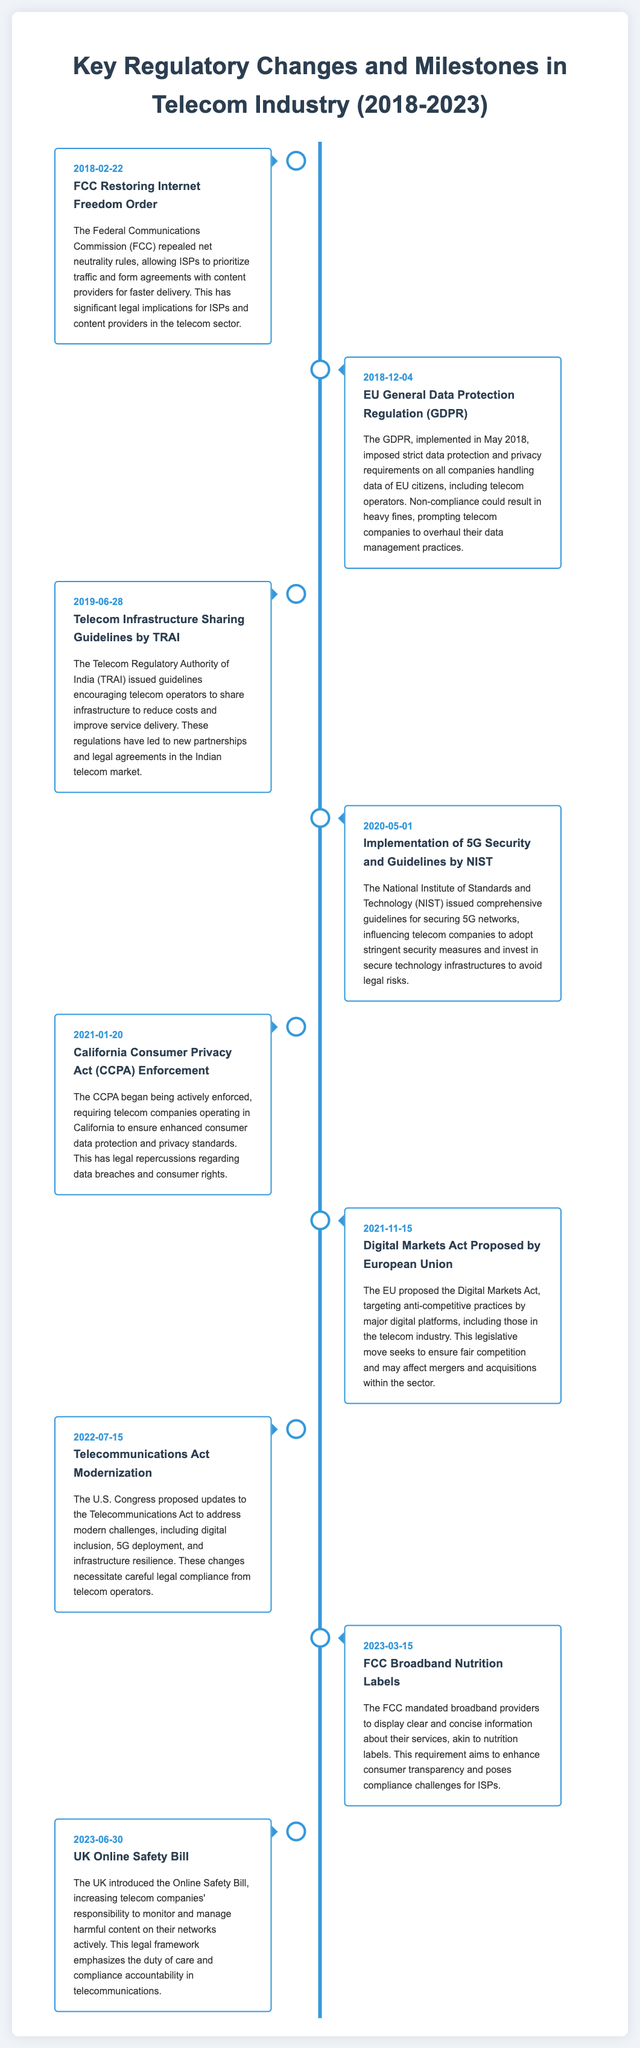What significant regulatory change occurred on February 22, 2018? The document states that the FCC repealed net neutrality rules on this date, allowing ISPs to prioritize traffic.
Answer: FCC Restoring Internet Freedom Order What data protection regulation was implemented in May 2018? The document mentions the GDPR, which imposed strict data protection requirements on telecom operators.
Answer: EU General Data Protection Regulation (GDPR) Which guidelines did TRAI issue on June 28, 2019? The document indicates that TRAI issued guidelines encouraging infrastructure sharing among telecom operators.
Answer: Telecom Infrastructure Sharing Guidelines What significant guideline was implemented by NIST on May 1, 2020? The document states that NIST issued guidelines for securing 5G networks, influencing telecom security practices.
Answer: Implementation of 5G Security and Guidelines What enforcement began on January 20, 2021, regarding consumer data? The document highlights that the CCPA began being actively enforced, impacting telecom companies in California.
Answer: California Consumer Privacy Act (CCPA) Enforcement What proposal did the EU introduce on November 15, 2021? The document explains that the EU proposed the Digital Markets Act, aiming to prevent anti-competitive practices.
Answer: Digital Markets Act Proposed What act did the U.S. Congress propose to modernize on July 15, 2022? The timeline notes proposed updates to the Telecommunications Act to address modern challenges.
Answer: Telecommunications Act Modernization What did the FCC mandate on March 15, 2023? The document states that the FCC mandated broadband providers to display clear service information.
Answer: FCC Broadband Nutrition Labels What legal framework was introduced in the UK on June 30, 2023? The document mentions the Online Safety Bill, which increases telecom companies' responsibility to manage content.
Answer: UK Online Safety Bill 